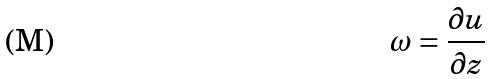Convert formula to latex. <formula><loc_0><loc_0><loc_500><loc_500>\omega = \frac { \partial u } { \partial z }</formula> 